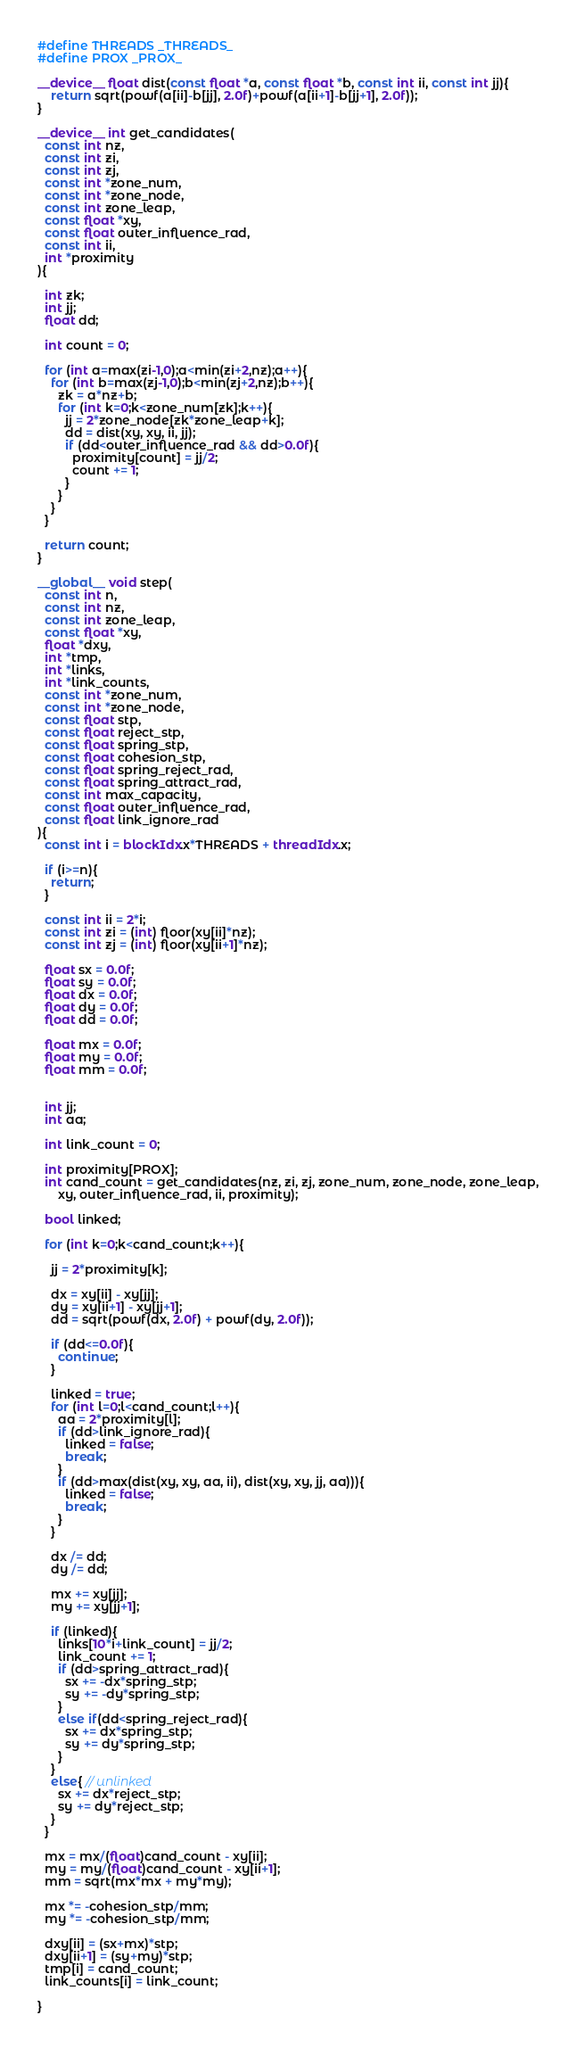Convert code to text. <code><loc_0><loc_0><loc_500><loc_500><_Cuda_>#define THREADS _THREADS_
#define PROX _PROX_

__device__ float dist(const float *a, const float *b, const int ii, const int jj){
    return sqrt(powf(a[ii]-b[jj], 2.0f)+powf(a[ii+1]-b[jj+1], 2.0f));
}

__device__ int get_candidates(
  const int nz,
  const int zi,
  const int zj,
  const int *zone_num,
  const int *zone_node,
  const int zone_leap,
  const float *xy,
  const float outer_influence_rad,
  const int ii,
  int *proximity
){

  int zk;
  int jj;
  float dd;

  int count = 0;

  for (int a=max(zi-1,0);a<min(zi+2,nz);a++){
    for (int b=max(zj-1,0);b<min(zj+2,nz);b++){
      zk = a*nz+b;
      for (int k=0;k<zone_num[zk];k++){
        jj = 2*zone_node[zk*zone_leap+k];
        dd = dist(xy, xy, ii, jj);
        if (dd<outer_influence_rad && dd>0.0f){
          proximity[count] = jj/2;
          count += 1;
        }
      }
    }
  }

  return count;
}

__global__ void step(
  const int n,
  const int nz,
  const int zone_leap,
  const float *xy,
  float *dxy,
  int *tmp,
  int *links,
  int *link_counts,
  const int *zone_num,
  const int *zone_node,
  const float stp,
  const float reject_stp,
  const float spring_stp,
  const float cohesion_stp,
  const float spring_reject_rad,
  const float spring_attract_rad,
  const int max_capacity,
  const float outer_influence_rad,
  const float link_ignore_rad
){
  const int i = blockIdx.x*THREADS + threadIdx.x;

  if (i>=n){
    return;
  }

  const int ii = 2*i;
  const int zi = (int) floor(xy[ii]*nz);
  const int zj = (int) floor(xy[ii+1]*nz);

  float sx = 0.0f;
  float sy = 0.0f;
  float dx = 0.0f;
  float dy = 0.0f;
  float dd = 0.0f;

  float mx = 0.0f;
  float my = 0.0f;
  float mm = 0.0f;


  int jj;
  int aa;

  int link_count = 0;

  int proximity[PROX];
  int cand_count = get_candidates(nz, zi, zj, zone_num, zone_node, zone_leap,
      xy, outer_influence_rad, ii, proximity);

  bool linked;

  for (int k=0;k<cand_count;k++){

    jj = 2*proximity[k];

    dx = xy[ii] - xy[jj];
    dy = xy[ii+1] - xy[jj+1];
    dd = sqrt(powf(dx, 2.0f) + powf(dy, 2.0f));

    if (dd<=0.0f){
      continue;
    }

    linked = true;
    for (int l=0;l<cand_count;l++){
      aa = 2*proximity[l];
      if (dd>link_ignore_rad){
        linked = false;
        break;
      }
      if (dd>max(dist(xy, xy, aa, ii), dist(xy, xy, jj, aa))){
        linked = false;
        break;
      }
    }

    dx /= dd;
    dy /= dd;

    mx += xy[jj];
    my += xy[jj+1];

    if (linked){
      links[10*i+link_count] = jj/2;
      link_count += 1;
      if (dd>spring_attract_rad){
        sx += -dx*spring_stp;
        sy += -dy*spring_stp;
      }
      else if(dd<spring_reject_rad){
        sx += dx*spring_stp;
        sy += dy*spring_stp;
      }
    }
    else{ // unlinked
      sx += dx*reject_stp;
      sy += dy*reject_stp;
    }
  }

  mx = mx/(float)cand_count - xy[ii];
  my = my/(float)cand_count - xy[ii+1];
  mm = sqrt(mx*mx + my*my);

  mx *= -cohesion_stp/mm;
  my *= -cohesion_stp/mm;

  dxy[ii] = (sx+mx)*stp;
  dxy[ii+1] = (sy+my)*stp;
  tmp[i] = cand_count;
  link_counts[i] = link_count;

}

</code> 